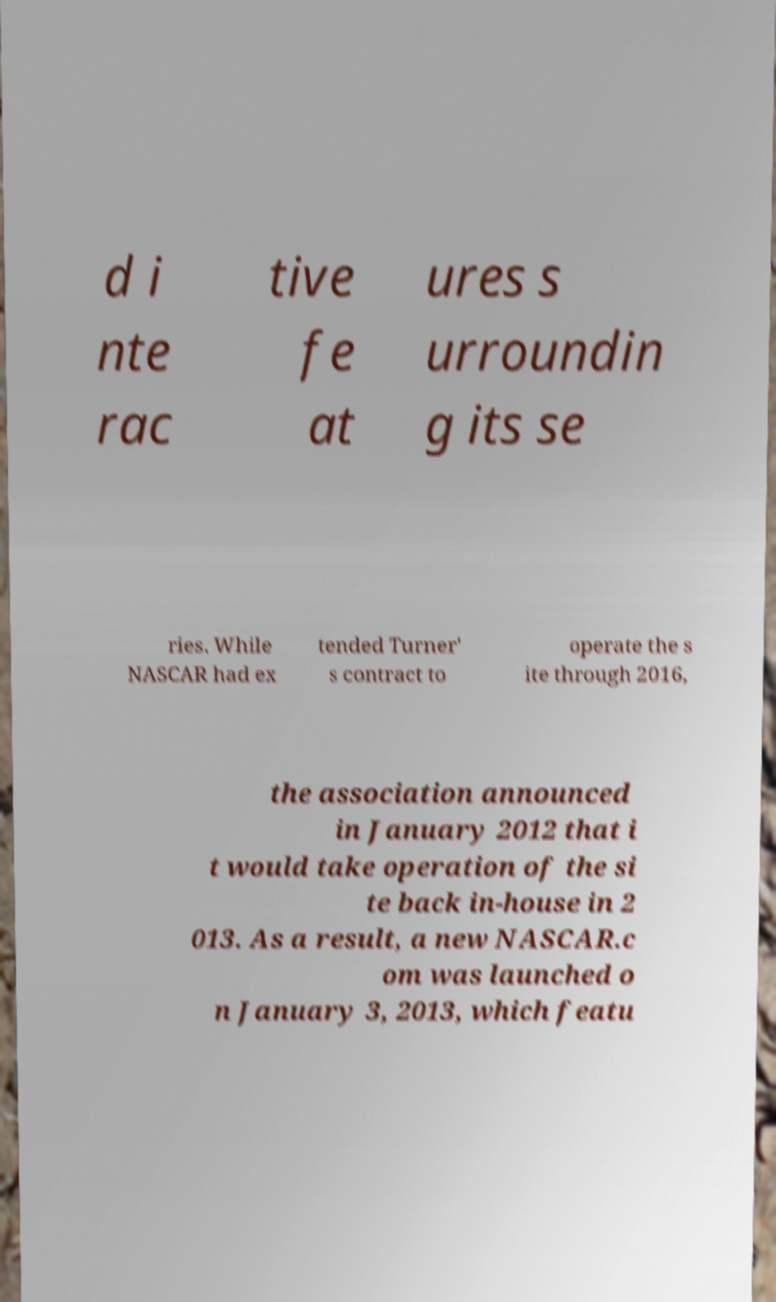For documentation purposes, I need the text within this image transcribed. Could you provide that? d i nte rac tive fe at ures s urroundin g its se ries. While NASCAR had ex tended Turner' s contract to operate the s ite through 2016, the association announced in January 2012 that i t would take operation of the si te back in-house in 2 013. As a result, a new NASCAR.c om was launched o n January 3, 2013, which featu 